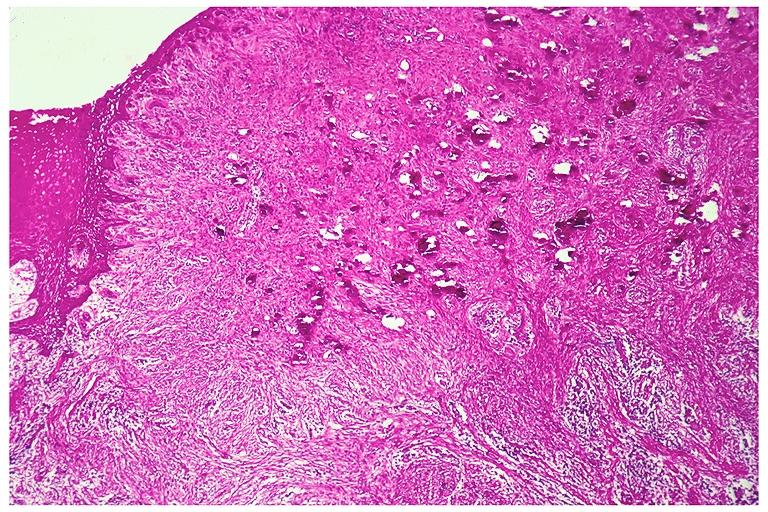s oral present?
Answer the question using a single word or phrase. Yes 